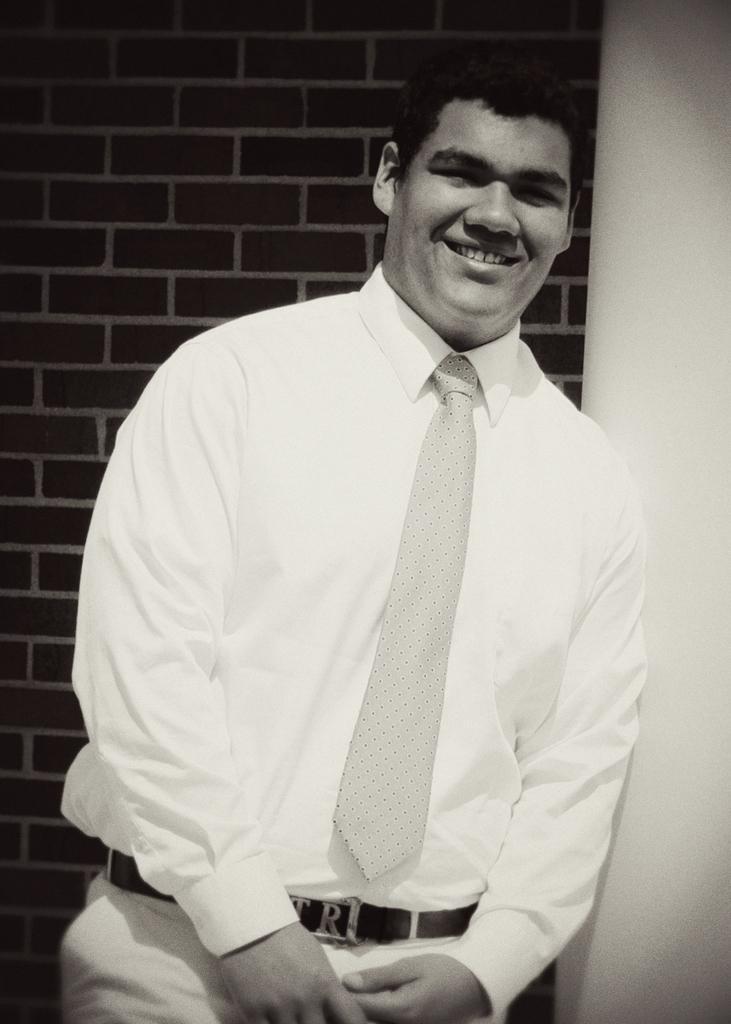How would you summarize this image in a sentence or two? In this picture I can see a man standing and smiling, and in the background there is a wall. 